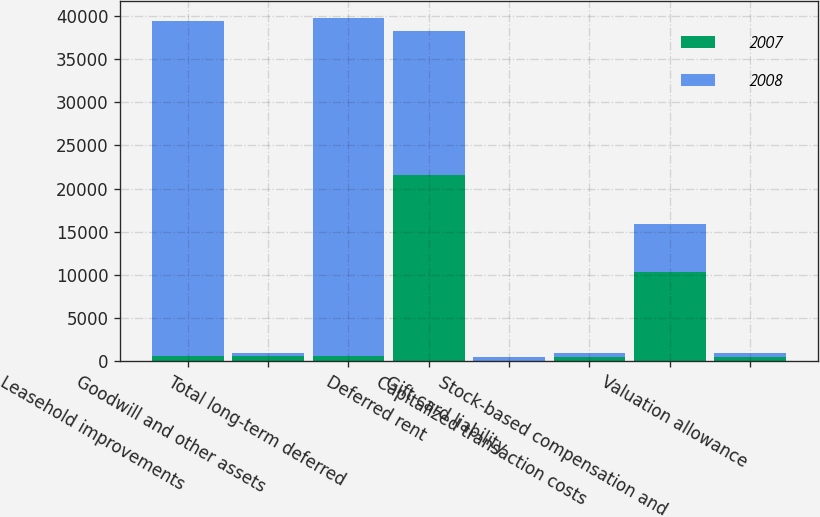Convert chart to OTSL. <chart><loc_0><loc_0><loc_500><loc_500><stacked_bar_chart><ecel><fcel>Leasehold improvements<fcel>Goodwill and other assets<fcel>Total long-term deferred<fcel>Deferred rent<fcel>Gift card liability<fcel>Capitalized transaction costs<fcel>Stock-based compensation and<fcel>Valuation allowance<nl><fcel>2007<fcel>581<fcel>641<fcel>581<fcel>21560<fcel>70<fcel>503<fcel>10292<fcel>485<nl><fcel>2008<fcel>38805<fcel>330<fcel>39135<fcel>16645<fcel>452<fcel>521<fcel>5555<fcel>521<nl></chart> 